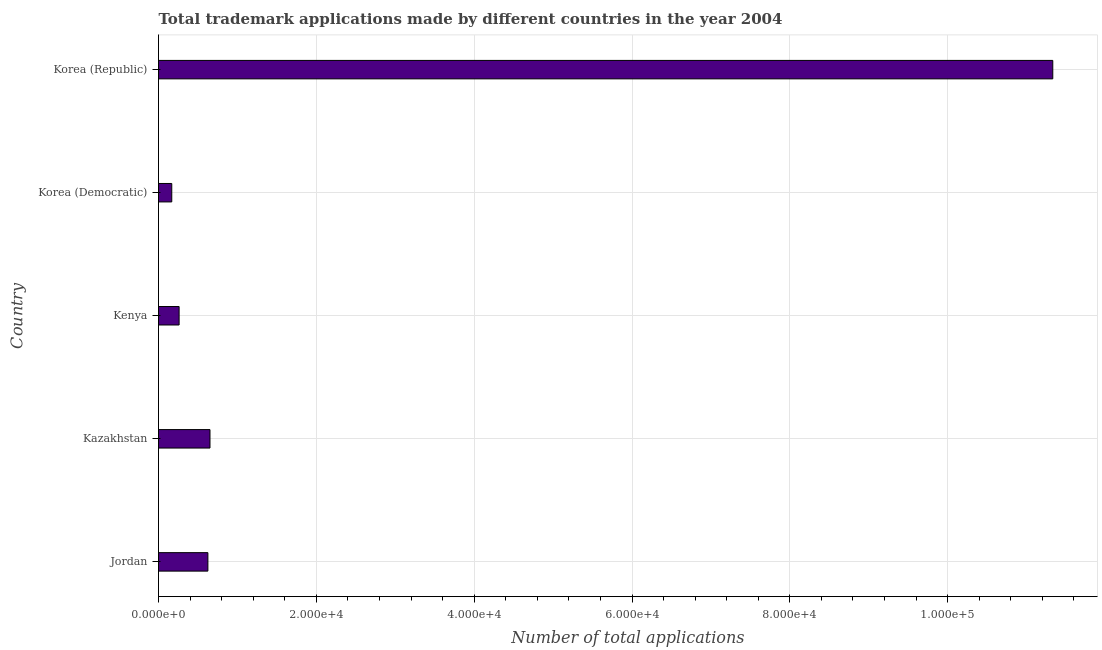Does the graph contain any zero values?
Your answer should be compact. No. Does the graph contain grids?
Your answer should be very brief. Yes. What is the title of the graph?
Give a very brief answer. Total trademark applications made by different countries in the year 2004. What is the label or title of the X-axis?
Provide a succinct answer. Number of total applications. What is the number of trademark applications in Korea (Democratic)?
Make the answer very short. 1679. Across all countries, what is the maximum number of trademark applications?
Ensure brevity in your answer.  1.13e+05. Across all countries, what is the minimum number of trademark applications?
Keep it short and to the point. 1679. In which country was the number of trademark applications maximum?
Your response must be concise. Korea (Republic). In which country was the number of trademark applications minimum?
Give a very brief answer. Korea (Democratic). What is the sum of the number of trademark applications?
Your answer should be very brief. 1.30e+05. What is the difference between the number of trademark applications in Jordan and Korea (Republic)?
Provide a succinct answer. -1.07e+05. What is the average number of trademark applications per country?
Your answer should be very brief. 2.61e+04. What is the median number of trademark applications?
Your answer should be compact. 6257. In how many countries, is the number of trademark applications greater than 68000 ?
Make the answer very short. 1. What is the ratio of the number of trademark applications in Jordan to that in Korea (Republic)?
Ensure brevity in your answer.  0.06. Is the number of trademark applications in Kazakhstan less than that in Korea (Republic)?
Provide a succinct answer. Yes. What is the difference between the highest and the second highest number of trademark applications?
Your response must be concise. 1.07e+05. What is the difference between the highest and the lowest number of trademark applications?
Your answer should be very brief. 1.12e+05. How many bars are there?
Keep it short and to the point. 5. Are all the bars in the graph horizontal?
Your response must be concise. Yes. Are the values on the major ticks of X-axis written in scientific E-notation?
Your response must be concise. Yes. What is the Number of total applications of Jordan?
Provide a succinct answer. 6257. What is the Number of total applications in Kazakhstan?
Give a very brief answer. 6523. What is the Number of total applications of Kenya?
Your response must be concise. 2609. What is the Number of total applications in Korea (Democratic)?
Keep it short and to the point. 1679. What is the Number of total applications in Korea (Republic)?
Provide a short and direct response. 1.13e+05. What is the difference between the Number of total applications in Jordan and Kazakhstan?
Make the answer very short. -266. What is the difference between the Number of total applications in Jordan and Kenya?
Give a very brief answer. 3648. What is the difference between the Number of total applications in Jordan and Korea (Democratic)?
Provide a succinct answer. 4578. What is the difference between the Number of total applications in Jordan and Korea (Republic)?
Keep it short and to the point. -1.07e+05. What is the difference between the Number of total applications in Kazakhstan and Kenya?
Offer a very short reply. 3914. What is the difference between the Number of total applications in Kazakhstan and Korea (Democratic)?
Offer a terse response. 4844. What is the difference between the Number of total applications in Kazakhstan and Korea (Republic)?
Your answer should be very brief. -1.07e+05. What is the difference between the Number of total applications in Kenya and Korea (Democratic)?
Your response must be concise. 930. What is the difference between the Number of total applications in Kenya and Korea (Republic)?
Offer a very short reply. -1.11e+05. What is the difference between the Number of total applications in Korea (Democratic) and Korea (Republic)?
Your answer should be very brief. -1.12e+05. What is the ratio of the Number of total applications in Jordan to that in Kazakhstan?
Keep it short and to the point. 0.96. What is the ratio of the Number of total applications in Jordan to that in Kenya?
Your response must be concise. 2.4. What is the ratio of the Number of total applications in Jordan to that in Korea (Democratic)?
Provide a succinct answer. 3.73. What is the ratio of the Number of total applications in Jordan to that in Korea (Republic)?
Keep it short and to the point. 0.06. What is the ratio of the Number of total applications in Kazakhstan to that in Kenya?
Your response must be concise. 2.5. What is the ratio of the Number of total applications in Kazakhstan to that in Korea (Democratic)?
Your answer should be very brief. 3.88. What is the ratio of the Number of total applications in Kazakhstan to that in Korea (Republic)?
Offer a very short reply. 0.06. What is the ratio of the Number of total applications in Kenya to that in Korea (Democratic)?
Your answer should be compact. 1.55. What is the ratio of the Number of total applications in Kenya to that in Korea (Republic)?
Ensure brevity in your answer.  0.02. What is the ratio of the Number of total applications in Korea (Democratic) to that in Korea (Republic)?
Provide a short and direct response. 0.01. 